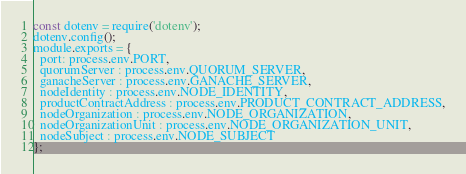<code> <loc_0><loc_0><loc_500><loc_500><_JavaScript_>const dotenv = require('dotenv');
dotenv.config();
module.exports = {
  port: process.env.PORT,
  quorumServer : process.env.QUORUM_SERVER,
  ganacheServer : process.env.GANACHE_SERVER,
  nodeIdentity : process.env.NODE_IDENTITY,
  productContractAddress : process.env.PRODUCT_CONTRACT_ADDRESS,
  nodeOrganization : process.env.NODE_ORGANIZATION,
  nodeOrganizationUnit : process.env.NODE_ORGANIZATION_UNIT,
  nodeSubject : process.env.NODE_SUBJECT
};
</code> 